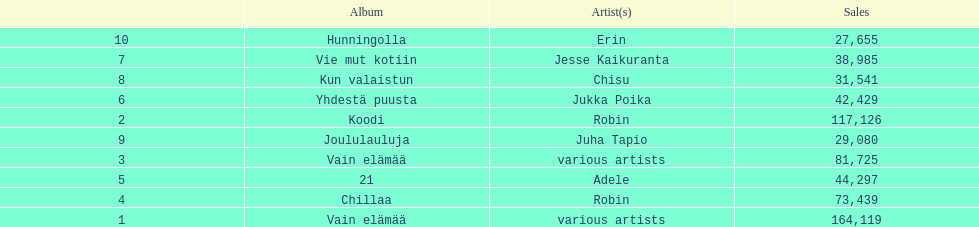What was the top selling album in this year? Vain elämää. 